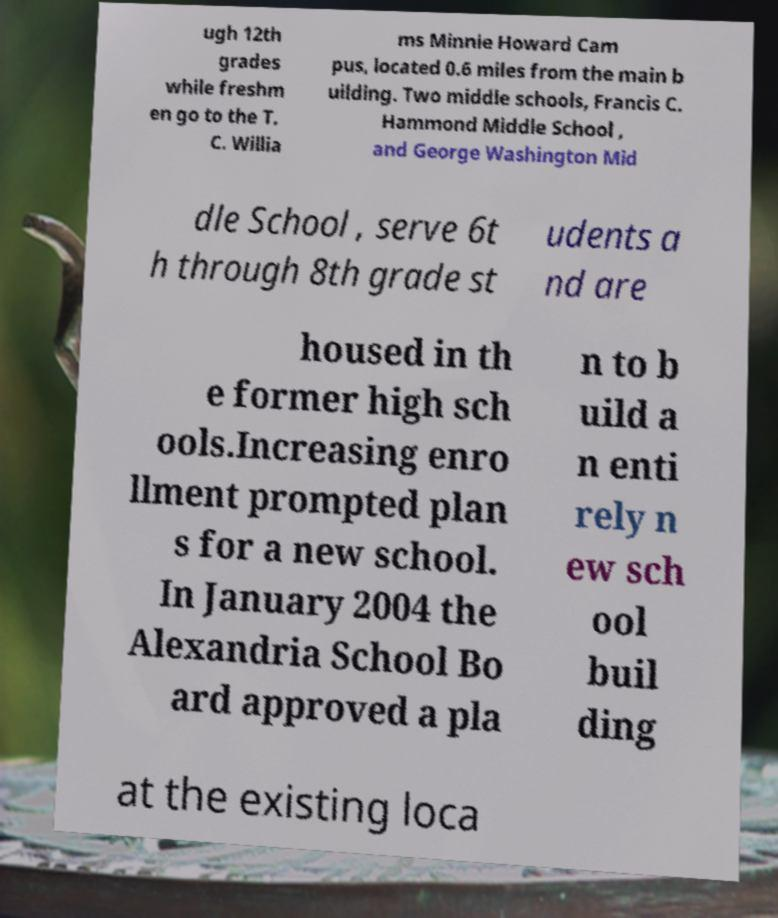Could you extract and type out the text from this image? ugh 12th grades while freshm en go to the T. C. Willia ms Minnie Howard Cam pus, located 0.6 miles from the main b uilding. Two middle schools, Francis C. Hammond Middle School , and George Washington Mid dle School , serve 6t h through 8th grade st udents a nd are housed in th e former high sch ools.Increasing enro llment prompted plan s for a new school. In January 2004 the Alexandria School Bo ard approved a pla n to b uild a n enti rely n ew sch ool buil ding at the existing loca 